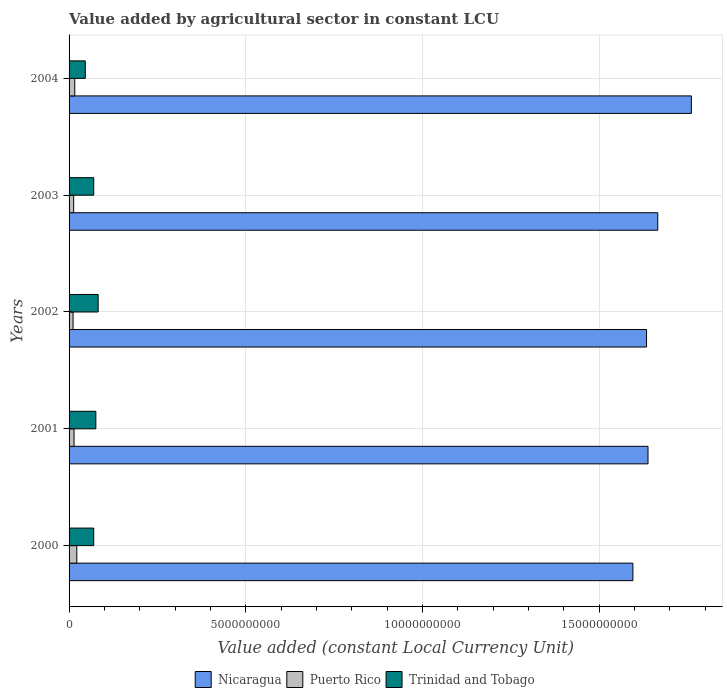How many groups of bars are there?
Your answer should be very brief. 5. Are the number of bars per tick equal to the number of legend labels?
Keep it short and to the point. Yes. What is the label of the 2nd group of bars from the top?
Keep it short and to the point. 2003. In how many cases, is the number of bars for a given year not equal to the number of legend labels?
Provide a succinct answer. 0. What is the value added by agricultural sector in Nicaragua in 2000?
Provide a short and direct response. 1.60e+1. Across all years, what is the maximum value added by agricultural sector in Puerto Rico?
Ensure brevity in your answer.  2.19e+08. Across all years, what is the minimum value added by agricultural sector in Puerto Rico?
Your answer should be very brief. 1.13e+08. In which year was the value added by agricultural sector in Nicaragua maximum?
Make the answer very short. 2004. In which year was the value added by agricultural sector in Trinidad and Tobago minimum?
Your answer should be compact. 2004. What is the total value added by agricultural sector in Trinidad and Tobago in the graph?
Give a very brief answer. 3.44e+09. What is the difference between the value added by agricultural sector in Trinidad and Tobago in 2000 and that in 2002?
Your answer should be very brief. -1.26e+08. What is the difference between the value added by agricultural sector in Trinidad and Tobago in 2001 and the value added by agricultural sector in Nicaragua in 2003?
Offer a terse response. -1.59e+1. What is the average value added by agricultural sector in Puerto Rico per year?
Provide a short and direct response. 1.53e+08. In the year 2003, what is the difference between the value added by agricultural sector in Nicaragua and value added by agricultural sector in Trinidad and Tobago?
Keep it short and to the point. 1.60e+1. What is the ratio of the value added by agricultural sector in Trinidad and Tobago in 2000 to that in 2002?
Provide a short and direct response. 0.85. What is the difference between the highest and the second highest value added by agricultural sector in Nicaragua?
Provide a succinct answer. 9.51e+08. What is the difference between the highest and the lowest value added by agricultural sector in Puerto Rico?
Your answer should be very brief. 1.06e+08. Is the sum of the value added by agricultural sector in Puerto Rico in 2001 and 2004 greater than the maximum value added by agricultural sector in Trinidad and Tobago across all years?
Keep it short and to the point. No. What does the 2nd bar from the top in 2003 represents?
Your answer should be compact. Puerto Rico. What does the 2nd bar from the bottom in 2001 represents?
Keep it short and to the point. Puerto Rico. Is it the case that in every year, the sum of the value added by agricultural sector in Puerto Rico and value added by agricultural sector in Trinidad and Tobago is greater than the value added by agricultural sector in Nicaragua?
Offer a very short reply. No. What is the difference between two consecutive major ticks on the X-axis?
Provide a short and direct response. 5.00e+09. Are the values on the major ticks of X-axis written in scientific E-notation?
Ensure brevity in your answer.  No. Does the graph contain grids?
Offer a very short reply. Yes. Where does the legend appear in the graph?
Provide a succinct answer. Bottom center. How many legend labels are there?
Your answer should be very brief. 3. How are the legend labels stacked?
Provide a short and direct response. Horizontal. What is the title of the graph?
Offer a terse response. Value added by agricultural sector in constant LCU. What is the label or title of the X-axis?
Keep it short and to the point. Value added (constant Local Currency Unit). What is the label or title of the Y-axis?
Ensure brevity in your answer.  Years. What is the Value added (constant Local Currency Unit) of Nicaragua in 2000?
Your response must be concise. 1.60e+1. What is the Value added (constant Local Currency Unit) of Puerto Rico in 2000?
Offer a terse response. 2.19e+08. What is the Value added (constant Local Currency Unit) in Trinidad and Tobago in 2000?
Provide a succinct answer. 6.97e+08. What is the Value added (constant Local Currency Unit) of Nicaragua in 2001?
Give a very brief answer. 1.64e+1. What is the Value added (constant Local Currency Unit) of Puerto Rico in 2001?
Your answer should be very brief. 1.41e+08. What is the Value added (constant Local Currency Unit) of Trinidad and Tobago in 2001?
Ensure brevity in your answer.  7.58e+08. What is the Value added (constant Local Currency Unit) in Nicaragua in 2002?
Offer a very short reply. 1.63e+1. What is the Value added (constant Local Currency Unit) in Puerto Rico in 2002?
Keep it short and to the point. 1.13e+08. What is the Value added (constant Local Currency Unit) in Trinidad and Tobago in 2002?
Make the answer very short. 8.24e+08. What is the Value added (constant Local Currency Unit) in Nicaragua in 2003?
Your answer should be compact. 1.67e+1. What is the Value added (constant Local Currency Unit) in Puerto Rico in 2003?
Provide a succinct answer. 1.30e+08. What is the Value added (constant Local Currency Unit) of Trinidad and Tobago in 2003?
Give a very brief answer. 6.98e+08. What is the Value added (constant Local Currency Unit) of Nicaragua in 2004?
Give a very brief answer. 1.76e+1. What is the Value added (constant Local Currency Unit) in Puerto Rico in 2004?
Your response must be concise. 1.61e+08. What is the Value added (constant Local Currency Unit) of Trinidad and Tobago in 2004?
Offer a terse response. 4.59e+08. Across all years, what is the maximum Value added (constant Local Currency Unit) of Nicaragua?
Your response must be concise. 1.76e+1. Across all years, what is the maximum Value added (constant Local Currency Unit) in Puerto Rico?
Make the answer very short. 2.19e+08. Across all years, what is the maximum Value added (constant Local Currency Unit) in Trinidad and Tobago?
Your answer should be compact. 8.24e+08. Across all years, what is the minimum Value added (constant Local Currency Unit) of Nicaragua?
Provide a short and direct response. 1.60e+1. Across all years, what is the minimum Value added (constant Local Currency Unit) in Puerto Rico?
Offer a terse response. 1.13e+08. Across all years, what is the minimum Value added (constant Local Currency Unit) of Trinidad and Tobago?
Ensure brevity in your answer.  4.59e+08. What is the total Value added (constant Local Currency Unit) in Nicaragua in the graph?
Keep it short and to the point. 8.29e+1. What is the total Value added (constant Local Currency Unit) of Puerto Rico in the graph?
Ensure brevity in your answer.  7.64e+08. What is the total Value added (constant Local Currency Unit) in Trinidad and Tobago in the graph?
Ensure brevity in your answer.  3.44e+09. What is the difference between the Value added (constant Local Currency Unit) of Nicaragua in 2000 and that in 2001?
Offer a terse response. -4.28e+08. What is the difference between the Value added (constant Local Currency Unit) in Puerto Rico in 2000 and that in 2001?
Give a very brief answer. 7.81e+07. What is the difference between the Value added (constant Local Currency Unit) in Trinidad and Tobago in 2000 and that in 2001?
Your answer should be compact. -6.05e+07. What is the difference between the Value added (constant Local Currency Unit) of Nicaragua in 2000 and that in 2002?
Give a very brief answer. -3.86e+08. What is the difference between the Value added (constant Local Currency Unit) of Puerto Rico in 2000 and that in 2002?
Make the answer very short. 1.06e+08. What is the difference between the Value added (constant Local Currency Unit) in Trinidad and Tobago in 2000 and that in 2002?
Make the answer very short. -1.26e+08. What is the difference between the Value added (constant Local Currency Unit) in Nicaragua in 2000 and that in 2003?
Your response must be concise. -7.04e+08. What is the difference between the Value added (constant Local Currency Unit) in Puerto Rico in 2000 and that in 2003?
Ensure brevity in your answer.  8.96e+07. What is the difference between the Value added (constant Local Currency Unit) of Trinidad and Tobago in 2000 and that in 2003?
Keep it short and to the point. -8.00e+05. What is the difference between the Value added (constant Local Currency Unit) in Nicaragua in 2000 and that in 2004?
Ensure brevity in your answer.  -1.66e+09. What is the difference between the Value added (constant Local Currency Unit) in Puerto Rico in 2000 and that in 2004?
Offer a terse response. 5.81e+07. What is the difference between the Value added (constant Local Currency Unit) in Trinidad and Tobago in 2000 and that in 2004?
Offer a very short reply. 2.38e+08. What is the difference between the Value added (constant Local Currency Unit) in Nicaragua in 2001 and that in 2002?
Offer a very short reply. 4.20e+07. What is the difference between the Value added (constant Local Currency Unit) in Puerto Rico in 2001 and that in 2002?
Offer a very short reply. 2.76e+07. What is the difference between the Value added (constant Local Currency Unit) in Trinidad and Tobago in 2001 and that in 2002?
Give a very brief answer. -6.60e+07. What is the difference between the Value added (constant Local Currency Unit) in Nicaragua in 2001 and that in 2003?
Make the answer very short. -2.76e+08. What is the difference between the Value added (constant Local Currency Unit) of Puerto Rico in 2001 and that in 2003?
Offer a very short reply. 1.14e+07. What is the difference between the Value added (constant Local Currency Unit) of Trinidad and Tobago in 2001 and that in 2003?
Make the answer very short. 5.97e+07. What is the difference between the Value added (constant Local Currency Unit) of Nicaragua in 2001 and that in 2004?
Provide a short and direct response. -1.23e+09. What is the difference between the Value added (constant Local Currency Unit) of Puerto Rico in 2001 and that in 2004?
Give a very brief answer. -2.00e+07. What is the difference between the Value added (constant Local Currency Unit) in Trinidad and Tobago in 2001 and that in 2004?
Give a very brief answer. 2.98e+08. What is the difference between the Value added (constant Local Currency Unit) of Nicaragua in 2002 and that in 2003?
Ensure brevity in your answer.  -3.18e+08. What is the difference between the Value added (constant Local Currency Unit) of Puerto Rico in 2002 and that in 2003?
Your response must be concise. -1.62e+07. What is the difference between the Value added (constant Local Currency Unit) of Trinidad and Tobago in 2002 and that in 2003?
Your response must be concise. 1.26e+08. What is the difference between the Value added (constant Local Currency Unit) in Nicaragua in 2002 and that in 2004?
Your response must be concise. -1.27e+09. What is the difference between the Value added (constant Local Currency Unit) of Puerto Rico in 2002 and that in 2004?
Keep it short and to the point. -4.76e+07. What is the difference between the Value added (constant Local Currency Unit) in Trinidad and Tobago in 2002 and that in 2004?
Your answer should be very brief. 3.64e+08. What is the difference between the Value added (constant Local Currency Unit) in Nicaragua in 2003 and that in 2004?
Provide a short and direct response. -9.51e+08. What is the difference between the Value added (constant Local Currency Unit) of Puerto Rico in 2003 and that in 2004?
Your answer should be compact. -3.14e+07. What is the difference between the Value added (constant Local Currency Unit) of Trinidad and Tobago in 2003 and that in 2004?
Offer a terse response. 2.39e+08. What is the difference between the Value added (constant Local Currency Unit) of Nicaragua in 2000 and the Value added (constant Local Currency Unit) of Puerto Rico in 2001?
Keep it short and to the point. 1.58e+1. What is the difference between the Value added (constant Local Currency Unit) of Nicaragua in 2000 and the Value added (constant Local Currency Unit) of Trinidad and Tobago in 2001?
Provide a short and direct response. 1.52e+1. What is the difference between the Value added (constant Local Currency Unit) of Puerto Rico in 2000 and the Value added (constant Local Currency Unit) of Trinidad and Tobago in 2001?
Give a very brief answer. -5.39e+08. What is the difference between the Value added (constant Local Currency Unit) of Nicaragua in 2000 and the Value added (constant Local Currency Unit) of Puerto Rico in 2002?
Ensure brevity in your answer.  1.58e+1. What is the difference between the Value added (constant Local Currency Unit) of Nicaragua in 2000 and the Value added (constant Local Currency Unit) of Trinidad and Tobago in 2002?
Keep it short and to the point. 1.51e+1. What is the difference between the Value added (constant Local Currency Unit) in Puerto Rico in 2000 and the Value added (constant Local Currency Unit) in Trinidad and Tobago in 2002?
Offer a terse response. -6.05e+08. What is the difference between the Value added (constant Local Currency Unit) of Nicaragua in 2000 and the Value added (constant Local Currency Unit) of Puerto Rico in 2003?
Provide a succinct answer. 1.58e+1. What is the difference between the Value added (constant Local Currency Unit) in Nicaragua in 2000 and the Value added (constant Local Currency Unit) in Trinidad and Tobago in 2003?
Offer a very short reply. 1.53e+1. What is the difference between the Value added (constant Local Currency Unit) of Puerto Rico in 2000 and the Value added (constant Local Currency Unit) of Trinidad and Tobago in 2003?
Give a very brief answer. -4.79e+08. What is the difference between the Value added (constant Local Currency Unit) of Nicaragua in 2000 and the Value added (constant Local Currency Unit) of Puerto Rico in 2004?
Ensure brevity in your answer.  1.58e+1. What is the difference between the Value added (constant Local Currency Unit) in Nicaragua in 2000 and the Value added (constant Local Currency Unit) in Trinidad and Tobago in 2004?
Offer a very short reply. 1.55e+1. What is the difference between the Value added (constant Local Currency Unit) of Puerto Rico in 2000 and the Value added (constant Local Currency Unit) of Trinidad and Tobago in 2004?
Keep it short and to the point. -2.40e+08. What is the difference between the Value added (constant Local Currency Unit) in Nicaragua in 2001 and the Value added (constant Local Currency Unit) in Puerto Rico in 2002?
Your answer should be compact. 1.63e+1. What is the difference between the Value added (constant Local Currency Unit) of Nicaragua in 2001 and the Value added (constant Local Currency Unit) of Trinidad and Tobago in 2002?
Your response must be concise. 1.56e+1. What is the difference between the Value added (constant Local Currency Unit) in Puerto Rico in 2001 and the Value added (constant Local Currency Unit) in Trinidad and Tobago in 2002?
Offer a terse response. -6.83e+08. What is the difference between the Value added (constant Local Currency Unit) of Nicaragua in 2001 and the Value added (constant Local Currency Unit) of Puerto Rico in 2003?
Your answer should be very brief. 1.63e+1. What is the difference between the Value added (constant Local Currency Unit) of Nicaragua in 2001 and the Value added (constant Local Currency Unit) of Trinidad and Tobago in 2003?
Give a very brief answer. 1.57e+1. What is the difference between the Value added (constant Local Currency Unit) of Puerto Rico in 2001 and the Value added (constant Local Currency Unit) of Trinidad and Tobago in 2003?
Offer a terse response. -5.57e+08. What is the difference between the Value added (constant Local Currency Unit) in Nicaragua in 2001 and the Value added (constant Local Currency Unit) in Puerto Rico in 2004?
Your response must be concise. 1.62e+1. What is the difference between the Value added (constant Local Currency Unit) in Nicaragua in 2001 and the Value added (constant Local Currency Unit) in Trinidad and Tobago in 2004?
Provide a succinct answer. 1.59e+1. What is the difference between the Value added (constant Local Currency Unit) of Puerto Rico in 2001 and the Value added (constant Local Currency Unit) of Trinidad and Tobago in 2004?
Ensure brevity in your answer.  -3.18e+08. What is the difference between the Value added (constant Local Currency Unit) in Nicaragua in 2002 and the Value added (constant Local Currency Unit) in Puerto Rico in 2003?
Provide a short and direct response. 1.62e+1. What is the difference between the Value added (constant Local Currency Unit) of Nicaragua in 2002 and the Value added (constant Local Currency Unit) of Trinidad and Tobago in 2003?
Keep it short and to the point. 1.56e+1. What is the difference between the Value added (constant Local Currency Unit) of Puerto Rico in 2002 and the Value added (constant Local Currency Unit) of Trinidad and Tobago in 2003?
Offer a very short reply. -5.85e+08. What is the difference between the Value added (constant Local Currency Unit) of Nicaragua in 2002 and the Value added (constant Local Currency Unit) of Puerto Rico in 2004?
Your answer should be compact. 1.62e+1. What is the difference between the Value added (constant Local Currency Unit) of Nicaragua in 2002 and the Value added (constant Local Currency Unit) of Trinidad and Tobago in 2004?
Provide a succinct answer. 1.59e+1. What is the difference between the Value added (constant Local Currency Unit) in Puerto Rico in 2002 and the Value added (constant Local Currency Unit) in Trinidad and Tobago in 2004?
Your response must be concise. -3.46e+08. What is the difference between the Value added (constant Local Currency Unit) in Nicaragua in 2003 and the Value added (constant Local Currency Unit) in Puerto Rico in 2004?
Ensure brevity in your answer.  1.65e+1. What is the difference between the Value added (constant Local Currency Unit) in Nicaragua in 2003 and the Value added (constant Local Currency Unit) in Trinidad and Tobago in 2004?
Your response must be concise. 1.62e+1. What is the difference between the Value added (constant Local Currency Unit) in Puerto Rico in 2003 and the Value added (constant Local Currency Unit) in Trinidad and Tobago in 2004?
Your answer should be very brief. -3.30e+08. What is the average Value added (constant Local Currency Unit) of Nicaragua per year?
Provide a succinct answer. 1.66e+1. What is the average Value added (constant Local Currency Unit) in Puerto Rico per year?
Make the answer very short. 1.53e+08. What is the average Value added (constant Local Currency Unit) of Trinidad and Tobago per year?
Provide a short and direct response. 6.87e+08. In the year 2000, what is the difference between the Value added (constant Local Currency Unit) of Nicaragua and Value added (constant Local Currency Unit) of Puerto Rico?
Your answer should be compact. 1.57e+1. In the year 2000, what is the difference between the Value added (constant Local Currency Unit) of Nicaragua and Value added (constant Local Currency Unit) of Trinidad and Tobago?
Your answer should be compact. 1.53e+1. In the year 2000, what is the difference between the Value added (constant Local Currency Unit) in Puerto Rico and Value added (constant Local Currency Unit) in Trinidad and Tobago?
Ensure brevity in your answer.  -4.78e+08. In the year 2001, what is the difference between the Value added (constant Local Currency Unit) in Nicaragua and Value added (constant Local Currency Unit) in Puerto Rico?
Keep it short and to the point. 1.62e+1. In the year 2001, what is the difference between the Value added (constant Local Currency Unit) of Nicaragua and Value added (constant Local Currency Unit) of Trinidad and Tobago?
Make the answer very short. 1.56e+1. In the year 2001, what is the difference between the Value added (constant Local Currency Unit) in Puerto Rico and Value added (constant Local Currency Unit) in Trinidad and Tobago?
Offer a terse response. -6.17e+08. In the year 2002, what is the difference between the Value added (constant Local Currency Unit) in Nicaragua and Value added (constant Local Currency Unit) in Puerto Rico?
Keep it short and to the point. 1.62e+1. In the year 2002, what is the difference between the Value added (constant Local Currency Unit) of Nicaragua and Value added (constant Local Currency Unit) of Trinidad and Tobago?
Give a very brief answer. 1.55e+1. In the year 2002, what is the difference between the Value added (constant Local Currency Unit) in Puerto Rico and Value added (constant Local Currency Unit) in Trinidad and Tobago?
Your response must be concise. -7.10e+08. In the year 2003, what is the difference between the Value added (constant Local Currency Unit) of Nicaragua and Value added (constant Local Currency Unit) of Puerto Rico?
Offer a terse response. 1.65e+1. In the year 2003, what is the difference between the Value added (constant Local Currency Unit) in Nicaragua and Value added (constant Local Currency Unit) in Trinidad and Tobago?
Offer a very short reply. 1.60e+1. In the year 2003, what is the difference between the Value added (constant Local Currency Unit) in Puerto Rico and Value added (constant Local Currency Unit) in Trinidad and Tobago?
Offer a terse response. -5.68e+08. In the year 2004, what is the difference between the Value added (constant Local Currency Unit) of Nicaragua and Value added (constant Local Currency Unit) of Puerto Rico?
Your answer should be very brief. 1.74e+1. In the year 2004, what is the difference between the Value added (constant Local Currency Unit) in Nicaragua and Value added (constant Local Currency Unit) in Trinidad and Tobago?
Your response must be concise. 1.72e+1. In the year 2004, what is the difference between the Value added (constant Local Currency Unit) of Puerto Rico and Value added (constant Local Currency Unit) of Trinidad and Tobago?
Keep it short and to the point. -2.98e+08. What is the ratio of the Value added (constant Local Currency Unit) in Nicaragua in 2000 to that in 2001?
Provide a short and direct response. 0.97. What is the ratio of the Value added (constant Local Currency Unit) of Puerto Rico in 2000 to that in 2001?
Offer a very short reply. 1.55. What is the ratio of the Value added (constant Local Currency Unit) in Trinidad and Tobago in 2000 to that in 2001?
Provide a short and direct response. 0.92. What is the ratio of the Value added (constant Local Currency Unit) in Nicaragua in 2000 to that in 2002?
Offer a very short reply. 0.98. What is the ratio of the Value added (constant Local Currency Unit) of Puerto Rico in 2000 to that in 2002?
Your answer should be compact. 1.93. What is the ratio of the Value added (constant Local Currency Unit) of Trinidad and Tobago in 2000 to that in 2002?
Provide a succinct answer. 0.85. What is the ratio of the Value added (constant Local Currency Unit) of Nicaragua in 2000 to that in 2003?
Offer a terse response. 0.96. What is the ratio of the Value added (constant Local Currency Unit) in Puerto Rico in 2000 to that in 2003?
Offer a very short reply. 1.69. What is the ratio of the Value added (constant Local Currency Unit) of Trinidad and Tobago in 2000 to that in 2003?
Provide a succinct answer. 1. What is the ratio of the Value added (constant Local Currency Unit) of Nicaragua in 2000 to that in 2004?
Offer a terse response. 0.91. What is the ratio of the Value added (constant Local Currency Unit) of Puerto Rico in 2000 to that in 2004?
Keep it short and to the point. 1.36. What is the ratio of the Value added (constant Local Currency Unit) of Trinidad and Tobago in 2000 to that in 2004?
Your response must be concise. 1.52. What is the ratio of the Value added (constant Local Currency Unit) of Nicaragua in 2001 to that in 2002?
Provide a short and direct response. 1. What is the ratio of the Value added (constant Local Currency Unit) in Puerto Rico in 2001 to that in 2002?
Offer a terse response. 1.24. What is the ratio of the Value added (constant Local Currency Unit) of Trinidad and Tobago in 2001 to that in 2002?
Offer a terse response. 0.92. What is the ratio of the Value added (constant Local Currency Unit) in Nicaragua in 2001 to that in 2003?
Your answer should be very brief. 0.98. What is the ratio of the Value added (constant Local Currency Unit) in Puerto Rico in 2001 to that in 2003?
Your answer should be very brief. 1.09. What is the ratio of the Value added (constant Local Currency Unit) in Trinidad and Tobago in 2001 to that in 2003?
Provide a short and direct response. 1.09. What is the ratio of the Value added (constant Local Currency Unit) in Nicaragua in 2001 to that in 2004?
Ensure brevity in your answer.  0.93. What is the ratio of the Value added (constant Local Currency Unit) of Puerto Rico in 2001 to that in 2004?
Your answer should be compact. 0.88. What is the ratio of the Value added (constant Local Currency Unit) of Trinidad and Tobago in 2001 to that in 2004?
Your answer should be very brief. 1.65. What is the ratio of the Value added (constant Local Currency Unit) of Nicaragua in 2002 to that in 2003?
Offer a very short reply. 0.98. What is the ratio of the Value added (constant Local Currency Unit) in Puerto Rico in 2002 to that in 2003?
Your response must be concise. 0.88. What is the ratio of the Value added (constant Local Currency Unit) in Trinidad and Tobago in 2002 to that in 2003?
Your answer should be very brief. 1.18. What is the ratio of the Value added (constant Local Currency Unit) of Nicaragua in 2002 to that in 2004?
Make the answer very short. 0.93. What is the ratio of the Value added (constant Local Currency Unit) in Puerto Rico in 2002 to that in 2004?
Ensure brevity in your answer.  0.7. What is the ratio of the Value added (constant Local Currency Unit) of Trinidad and Tobago in 2002 to that in 2004?
Offer a terse response. 1.79. What is the ratio of the Value added (constant Local Currency Unit) of Nicaragua in 2003 to that in 2004?
Ensure brevity in your answer.  0.95. What is the ratio of the Value added (constant Local Currency Unit) of Puerto Rico in 2003 to that in 2004?
Your answer should be very brief. 0.8. What is the ratio of the Value added (constant Local Currency Unit) in Trinidad and Tobago in 2003 to that in 2004?
Offer a very short reply. 1.52. What is the difference between the highest and the second highest Value added (constant Local Currency Unit) in Nicaragua?
Ensure brevity in your answer.  9.51e+08. What is the difference between the highest and the second highest Value added (constant Local Currency Unit) in Puerto Rico?
Keep it short and to the point. 5.81e+07. What is the difference between the highest and the second highest Value added (constant Local Currency Unit) in Trinidad and Tobago?
Provide a short and direct response. 6.60e+07. What is the difference between the highest and the lowest Value added (constant Local Currency Unit) of Nicaragua?
Provide a succinct answer. 1.66e+09. What is the difference between the highest and the lowest Value added (constant Local Currency Unit) in Puerto Rico?
Give a very brief answer. 1.06e+08. What is the difference between the highest and the lowest Value added (constant Local Currency Unit) of Trinidad and Tobago?
Provide a short and direct response. 3.64e+08. 